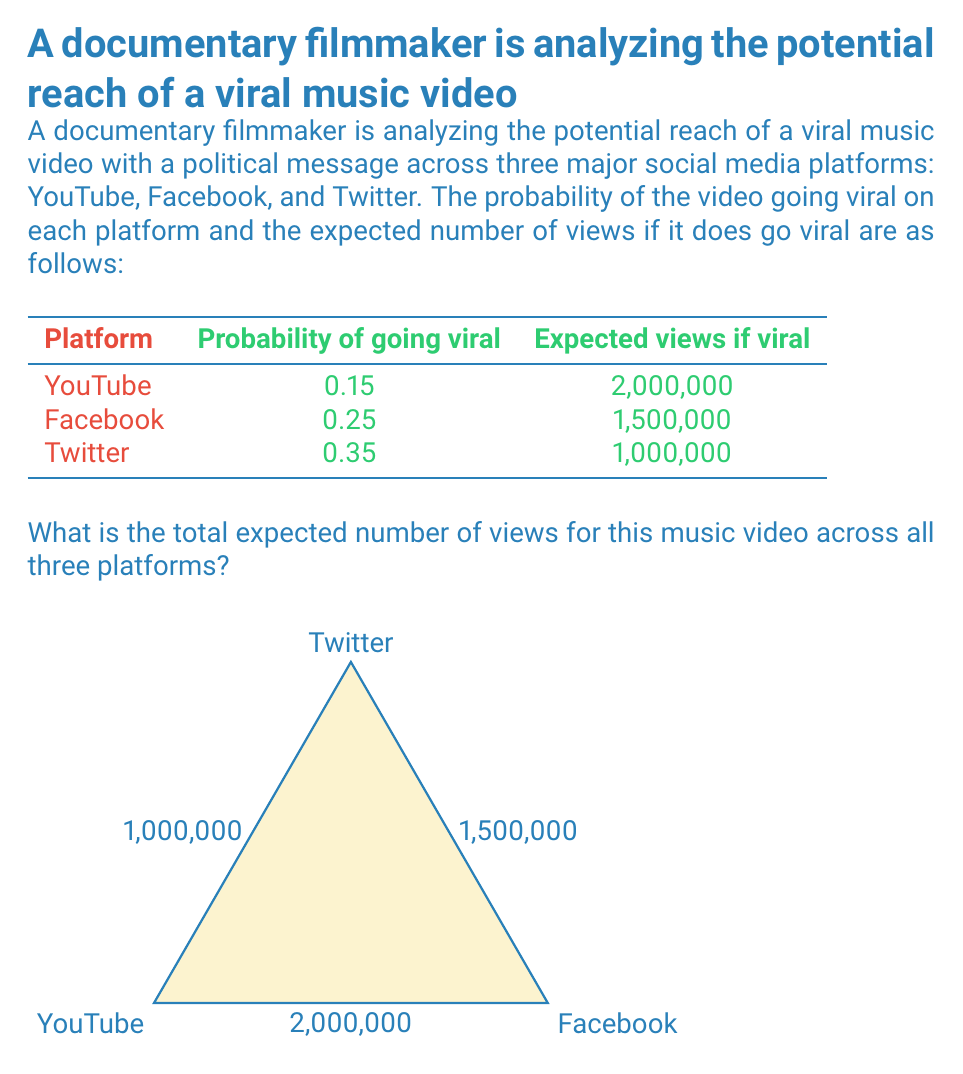Teach me how to tackle this problem. To solve this problem, we need to calculate the expected value for each platform and then sum them up. The expected value is calculated by multiplying the probability of the event occurring by the value if it does occur.

1. For YouTube:
   Expected views = Probability × Views if viral
   $E(\text{YouTube}) = 0.15 \times 2,000,000 = 300,000$

2. For Facebook:
   $E(\text{Facebook}) = 0.25 \times 1,500,000 = 375,000$

3. For Twitter:
   $E(\text{Twitter}) = 0.35 \times 1,000,000 = 350,000$

4. Total expected views:
   $E(\text{Total}) = E(\text{YouTube}) + E(\text{Facebook}) + E(\text{Twitter})$
   $E(\text{Total}) = 300,000 + 375,000 + 350,000 = 1,025,000$

Therefore, the total expected number of views across all three platforms is 1,025,000.
Answer: 1,025,000 views 